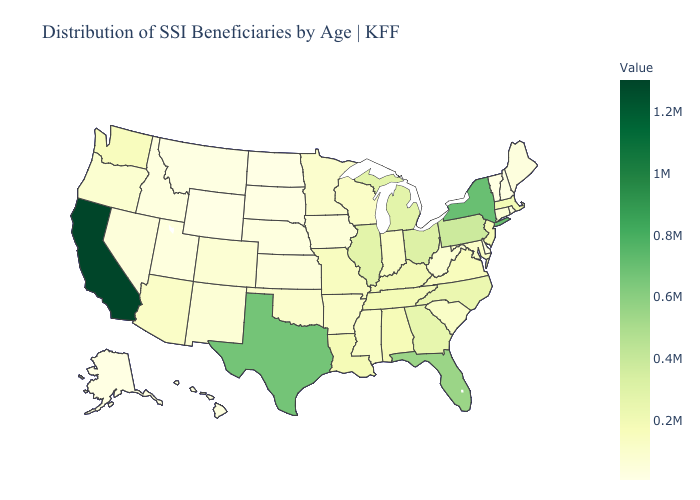Does California have the highest value in the USA?
Be succinct. Yes. Among the states that border West Virginia , does Maryland have the lowest value?
Give a very brief answer. Yes. Which states have the lowest value in the USA?
Concise answer only. Wyoming. Among the states that border Arkansas , which have the highest value?
Be succinct. Texas. Among the states that border Louisiana , does Mississippi have the highest value?
Answer briefly. No. Among the states that border Louisiana , does Texas have the lowest value?
Give a very brief answer. No. Does California have the highest value in the West?
Keep it brief. Yes. 